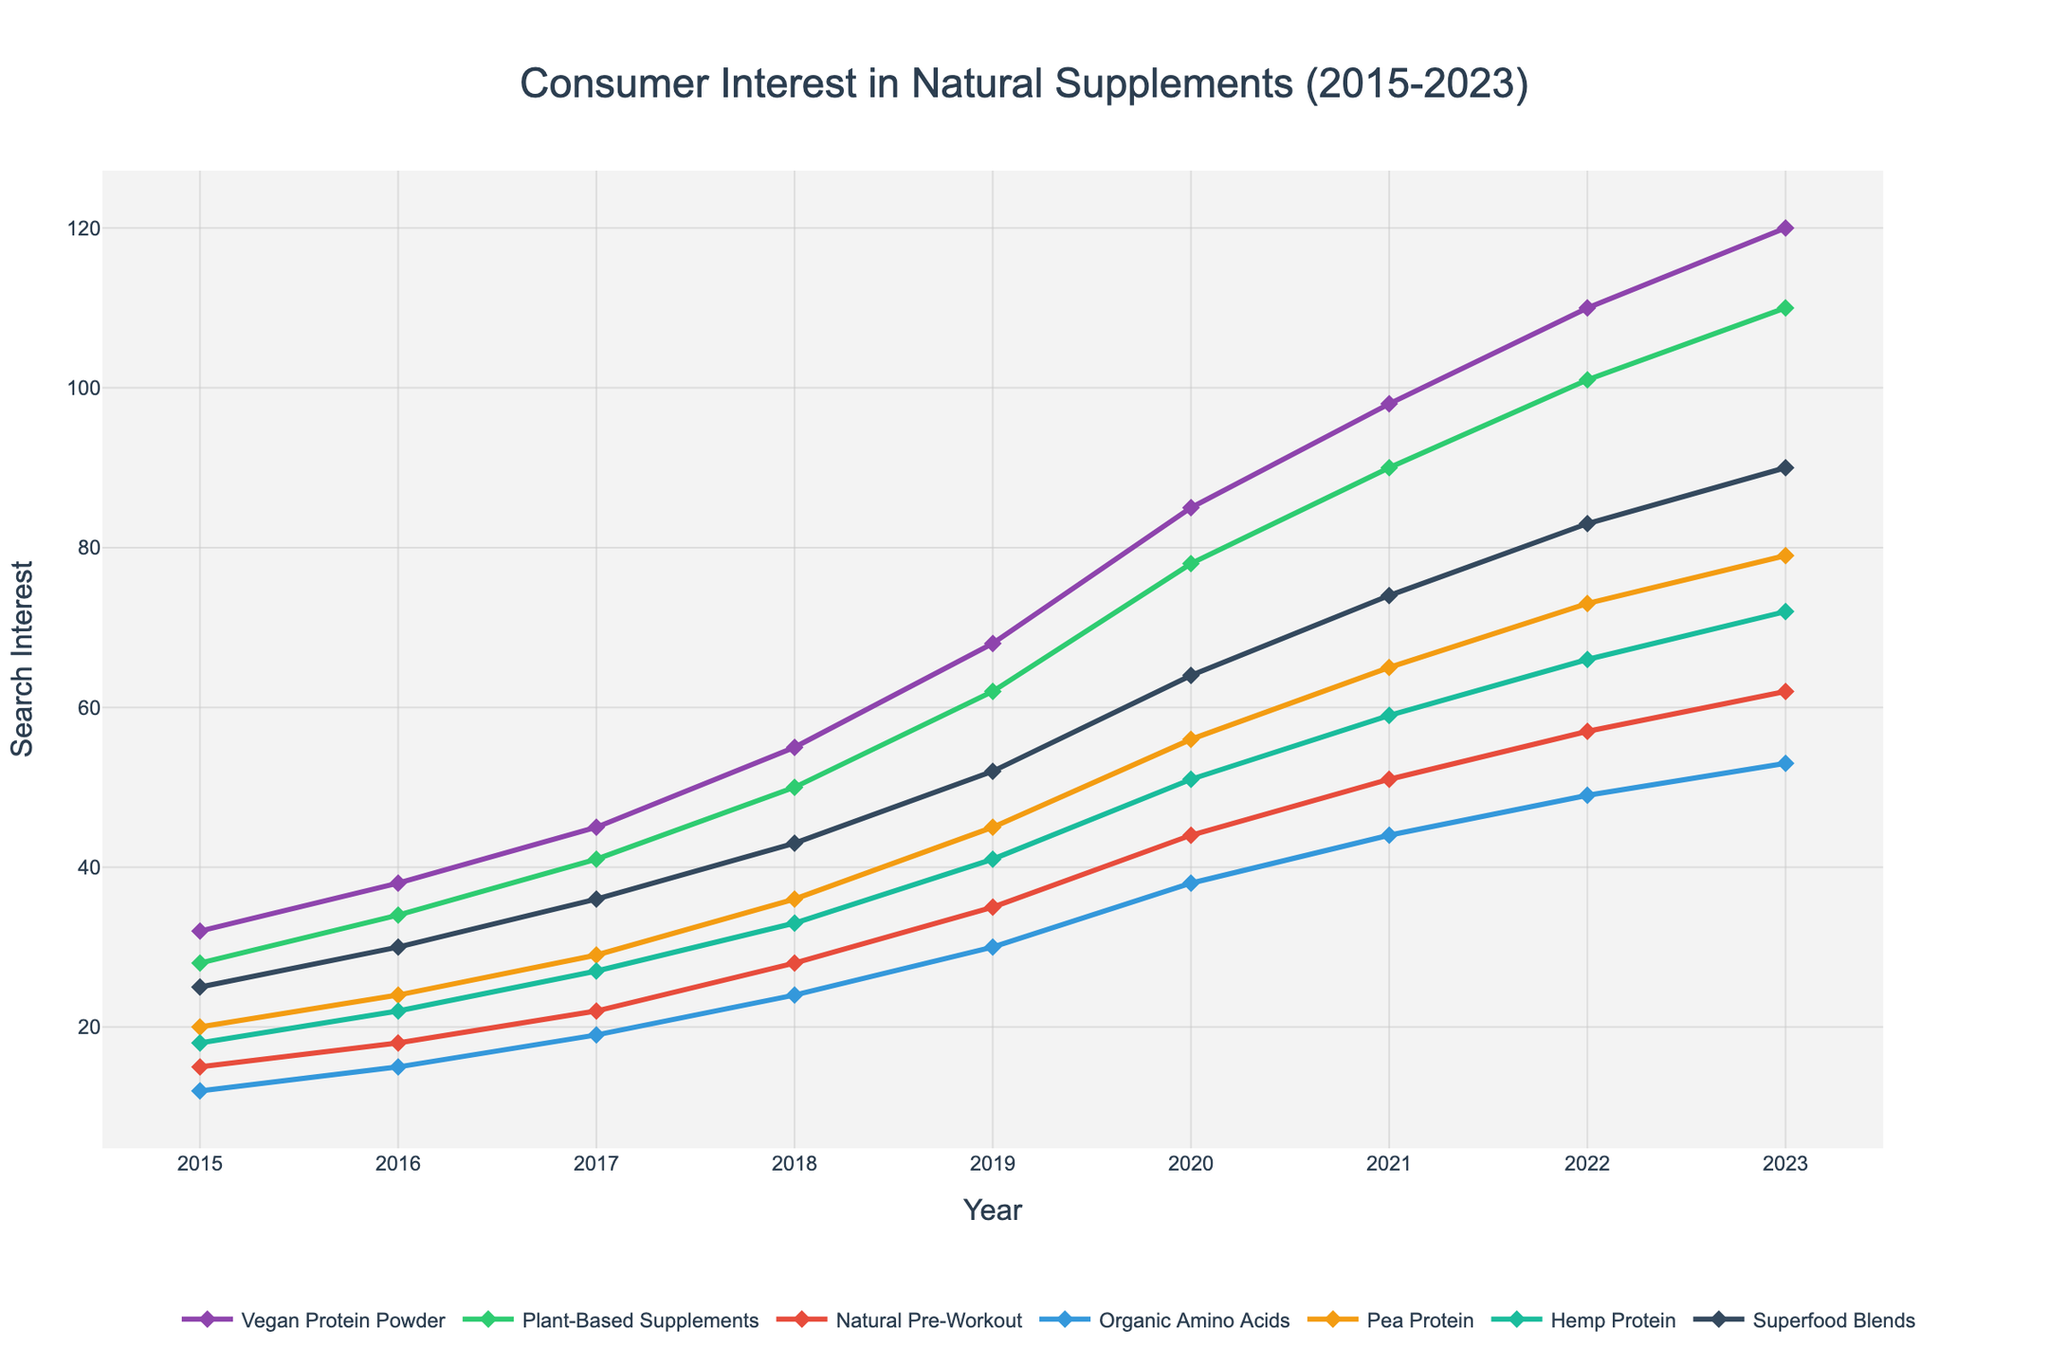What key term shows the highest consumer interest in 2023? Check the height of each line's endpoint in 2023. The 'Vegan Protein Powder' line is the highest at 120.
Answer: Vegan Protein Powder Which key term has shown the most consistent growth from 2015 to 2023? Observe the slope of each line from 2015 to 2023. 'Vegan Protein Powder' shows a consistently steep upward trend.
Answer: Vegan Protein Powder Compare the search interest in 'Pea Protein' and 'Hemp Protein' in 2020. Which one is higher and by how much? Look at the points for 'Pea Protein' and 'Hemp Protein' in 2020: Pea Protein is at 56 and Hemp Protein is at 51, so Pea Protein is higher by 5.
Answer: Pea Protein by 5 How did the search interest for 'Natural Pre-Workout' change between 2018 and 2023? Find the 'Natural Pre-Workout' values for 2018 (28) and 2023 (62). The change is 62 - 28.
Answer: Increased by 34 What is the average search interest in 'Organic Amino Acids' over the given period? Sum the search interests from 2015 to 2023 and divide by the number of years: (12 + 15 + 19 + 24 + 30 + 38 + 44 + 49 + 53) / 9.
Answer: Approximately 31.6 During which year did the 'Superfood Blends' see a significant increase in interest? Observe the 'Superfood Blends' line for the steepest increase, which occurs between 2019 (52) and 2020 (64).
Answer: 2019-2020 Which key term had a search interest of around 100 in 2022, and how does this compare to its interest in 2023? 'Plant-Based Supplements' had a search interest of 101 in 2022 and increased to 110 in 2023.
Answer: 'Plant-Based Supplements' increased by 9 Calculate the total increase in consumer interest for 'Hemp Protein' from 2015 to 2023. Subtract the value in 2015 (18) from the value in 2023 (72).
Answer: Increased by 54 Which term intersects with 'Vegan Protein Powder' between 2015 and 2023 and at what point does it diverge permanently? 'Plant-Based Supplements' intersects with 'Vegan Protein Powder' at 2021. After 2021, 'Vegan Protein Powder' remains higher.
Answer: 2021 Compare the rate of increase between 'Vegan Protein Powder' and 'Superfood Blends' from 2015 to 2023. Which one increased at a faster rate and by how much? 'Vegan Protein Powder': (120 - 32) / 8 = 11 per year; 'Superfood Blends': (90 - 25) / 8 = 8.125 per year. 'Vegan Protein Powder' increased faster by 2.875 per year.
Answer: Vegan Protein Powder by 2.875 per year 